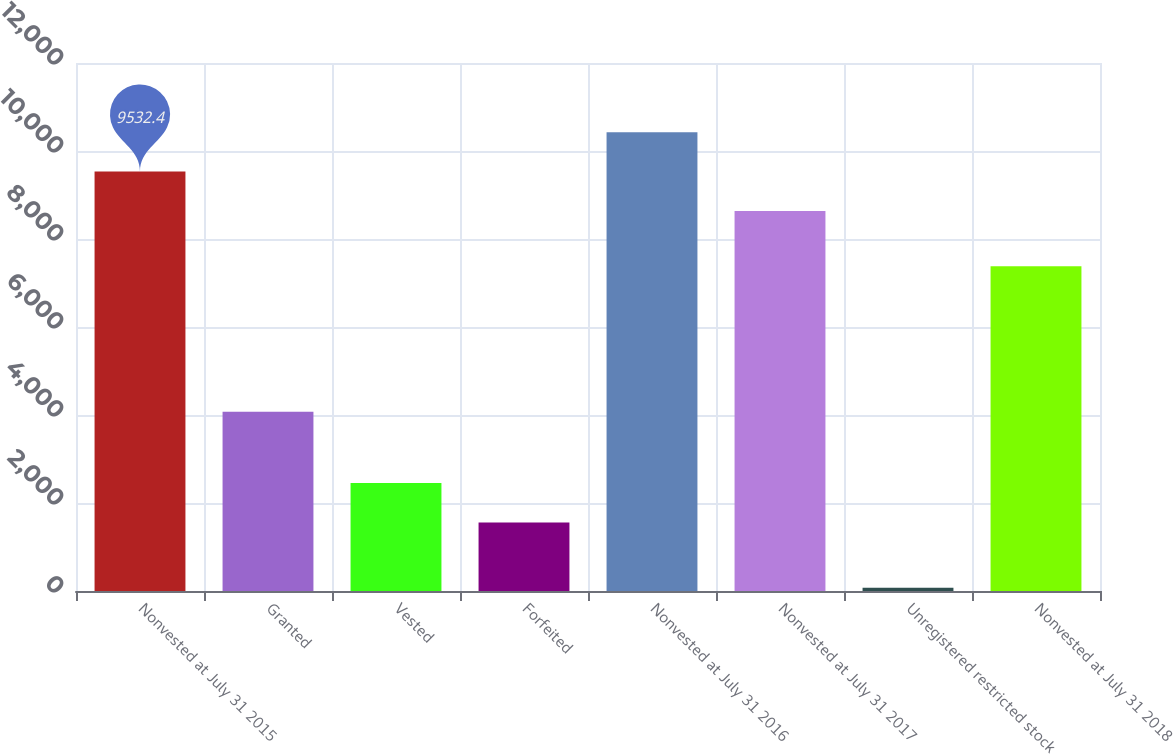Convert chart. <chart><loc_0><loc_0><loc_500><loc_500><bar_chart><fcel>Nonvested at July 31 2015<fcel>Granted<fcel>Vested<fcel>Forfeited<fcel>Nonvested at July 31 2016<fcel>Nonvested at July 31 2017<fcel>Unregistered restricted stock<fcel>Nonvested at July 31 2018<nl><fcel>9532.4<fcel>4072<fcel>2453.4<fcel>1557<fcel>10428.8<fcel>8636<fcel>75<fcel>7383<nl></chart> 